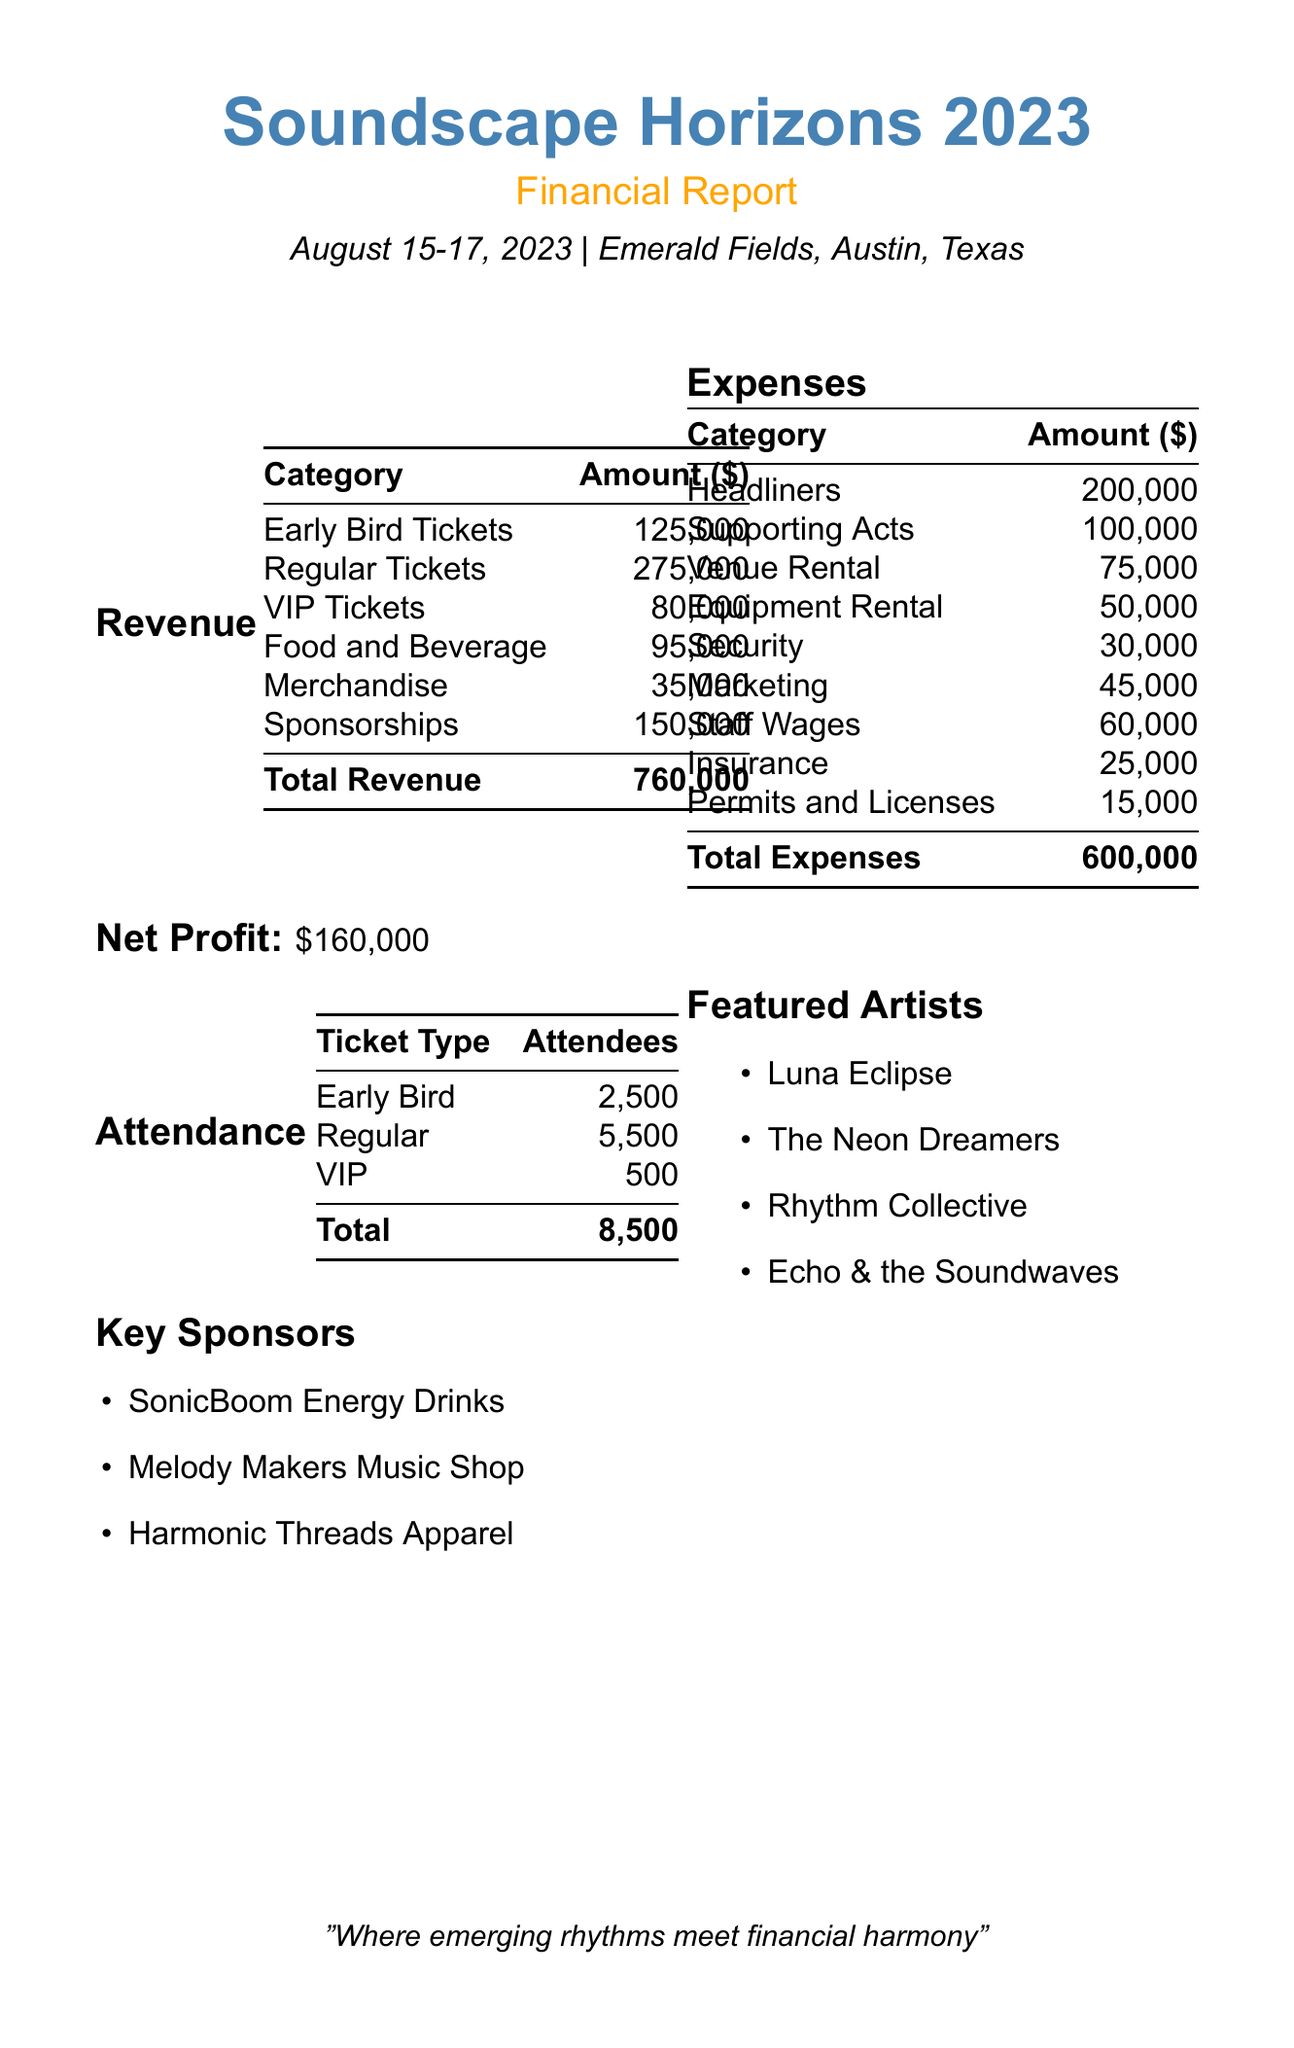what is the total revenue? The total revenue is calculated by summing all the revenue sources listed in the document: early bird tickets, regular tickets, VIP tickets, food and beverage, merchandise, and sponsorships.
Answer: 760,000 what are the total expenses? The total expenses are calculated by summing all the expenses listed in the document: artist fees, venue rental, equipment rental, security, marketing, staff wages, insurance, and permits and licenses.
Answer: 600,000 what is the net profit? The net profit is calculated by subtracting total expenses from total revenue.
Answer: 160,000 how many total attendees were at the festival? The total attendees are provided directly in the attendance section of the document.
Answer: 8,500 who were the featured artists? The featured artists are directly listed in the document as part of the featured artists section.
Answer: Luna Eclipse, The Neon Dreamers, Rhythm Collective, Echo & the Soundwaves what was the amount generated from sponsorships? The sponsorship revenue is specified in the revenue section.
Answer: 150,000 how much were artist fees for headliners? The headliner artist fees are directly stated in the expenses section of the document.
Answer: 200,000 what was the venue rental cost? The venue rental cost is specified in the expenses section of the document.
Answer: 75,000 what is the date of the event? The date of the event is mentioned at the top of the document.
Answer: August 15-17, 2023 